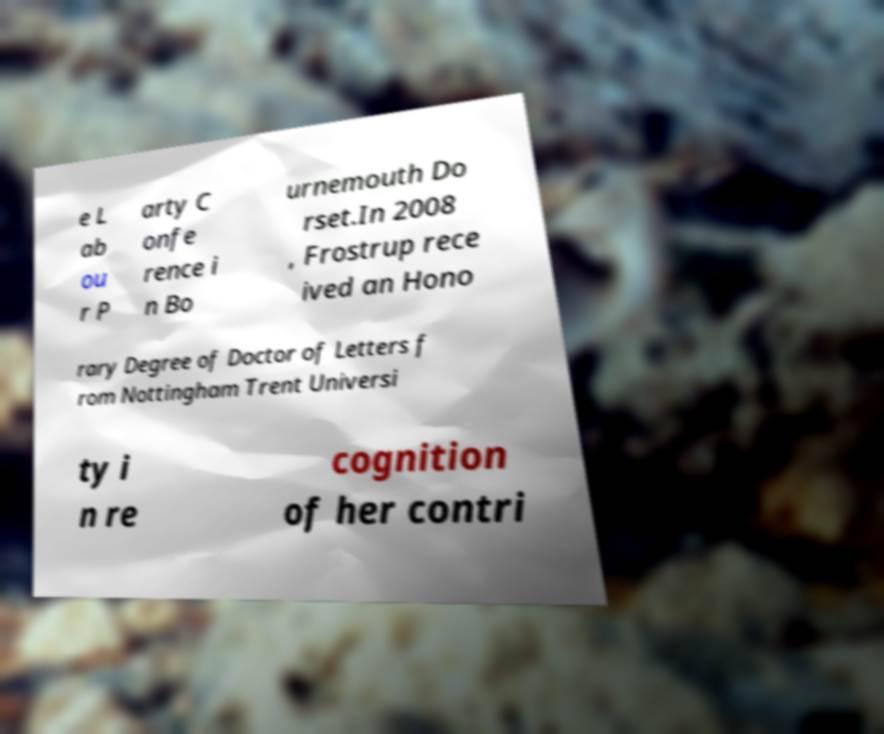Please identify and transcribe the text found in this image. e L ab ou r P arty C onfe rence i n Bo urnemouth Do rset.In 2008 , Frostrup rece ived an Hono rary Degree of Doctor of Letters f rom Nottingham Trent Universi ty i n re cognition of her contri 